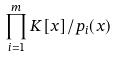Convert formula to latex. <formula><loc_0><loc_0><loc_500><loc_500>\prod _ { i = 1 } ^ { m } K [ x ] / p _ { i } ( x )</formula> 